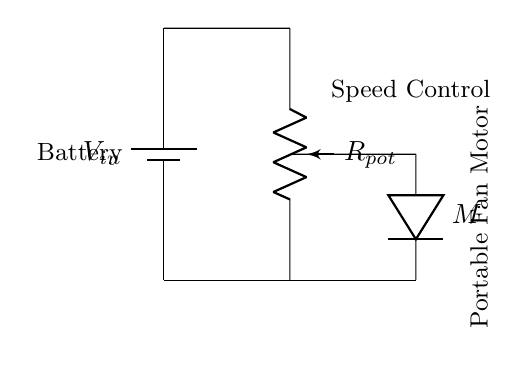What is the type of motor used in this circuit? The symbol used in the diagram represents a direct current motor, commonly abbreviated as "M", which is typically used for driving portable fans.
Answer: Direct current What component is used to control the speed of the fan? The potentiometer labeled as Rpot adjusts the resistance in the circuit, thereby varying the voltage applied to the motor and controlling its speed.
Answer: Potentiometer What is the power source for this circuit? The circuit diagram indicates the presence of a battery, labeled as Vin, which provides the necessary voltage for the entire circuit to function.
Answer: Battery What is the number of resistors in this circuit? The diagram clearly shows only one resistive element, which is the potentiometer, designated as Rpot, used for voltage division in the circuit.
Answer: One How is the potentiometer connected in this voltage divider? The potentiometer is connected in parallel across the battery and in series with the fan motor, enabling it to divide the input voltage and adjust the speed based on resistance settings.
Answer: In series with motor What happens to the fan speed as the resistance of the potentiometer increases? Increasing the resistance of the potentiometer decreases the current through the motor, which results in a lower voltage across it, thereby reducing the fan speed.
Answer: Decreases speed What does the voltage divider do in this circuit? The voltage divider function allows for the adjustment of the output voltage supplied to the fan by varying the resistance of the potentiometer, effectively regulating the fan's speed.
Answer: Regulates speed 